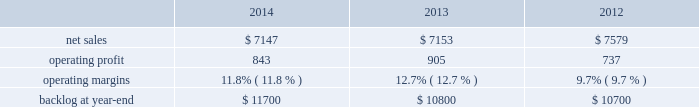Mission systems and training our mst business segment provides ship and submarine mission and combat systems ; mission systems and sensors for rotary and fixed-wing aircraft ; sea and land-based missile defense systems ; radar systems ; littoral combat ships ; simulation and training services ; and unmanned systems and technologies .
Mst 2019s major programs include aegis combat system ( aegis ) , littoral combat ship ( lcs ) , mh-60 , tpq-53 radar system and mk-41 vertical launching system .
Mst 2019s operating results included the following ( in millions ) : .
2014 compared to 2013 mst 2019s net sales for 2014 were comparable to 2013 .
Net sales decreased by approximately $ 85 million for undersea systems programs due to decreased volume and deliveries ; and about $ 55 million related to the settlements of contract cost matters on certain programs ( including a portion of the terminated presidential helicopter program ) in 2013 that were not repeated in 2014 .
The decreases were offset by higher net sales of approximately $ 80 million for integrated warfare systems and sensors programs due to increased volume ( primarily space fence ) ; and approximately $ 40 million for training and logistics solutions programs due to increased deliveries ( primarily close combat tactical trainer ) .
Mst 2019s operating profit for 2014 decreased $ 62 million , or 7% ( 7 % ) , compared to 2013 .
The decrease was primarily attributable to lower operating profit of approximately $ 120 million related to the settlements of contract cost matters on certain programs ( including a portion of the terminated presidential helicopter program ) in 2013 that were not repeated in 2014 ; and approximately $ 45 million due to higher reserves recorded on certain training and logistics solutions programs .
The decreases were partially offset by higher operating profit of approximately $ 45 million for performance matters and reserves recorded in 2013 that were not repeated in 2014 ; and about $ 60 million for various programs due to increased risk retirements ( including mh-60 and radar surveillance programs ) .
Adjustments not related to volume , including net profit booking rate adjustments and other matters , were approximately $ 50 million lower for 2014 compared to 2013 .
2013 compared to 2012 mst 2019s net sales for 2013 decreased $ 426 million , or 6% ( 6 % ) , compared to 2012 .
The decrease was primarily attributable to lower net sales of approximately $ 275 million for various ship and aviation systems programs due to lower volume ( primarily ptds as final surveillance system deliveries occurred during the second quarter of 2012 ) ; about $ 195 million for various integrated warfare systems and sensors programs ( primarily naval systems ) due to lower volume ; approximately $ 65 million for various training and logistics programs due to lower volume ; and about $ 55 million for the aegis program due to lower volume .
The decreases were partially offset by higher net sales of about $ 155 million for the lcs program due to increased volume .
Mst 2019s operating profit for 2013 increased $ 168 million , or 23% ( 23 % ) , compared to 2012 .
The increase was primarily attributable to higher operating profit of approximately $ 120 million related to the settlement of contract cost matters on certain programs ( including a portion of the terminated presidential helicopter program ) ; about $ 55 million for integrated warfare systems and sensors programs ( primarily radar and halifax class modernization programs ) due to increased risk retirements ; and approximately $ 30 million for undersea systems programs due to increased risk retirements .
The increases were partially offset by lower operating profit of about $ 55 million for training and logistics programs , primarily due to the recording of approximately $ 30 million of charges mostly related to lower-of-cost-or-market considerations ; and about $ 25 million for ship and aviation systems programs ( primarily ptds ) due to lower risk retirements and volume .
Operating profit related to the lcs program was comparable .
Adjustments not related to volume , including net profit booking rate adjustments and other matters , were approximately $ 170 million higher for 2013 compared to 2012 .
Backlog backlog increased in 2014 compared to 2013 primarily due to higher orders on new program starts ( such as space fence ) .
Backlog increased slightly in 2013 compared to 2012 mainly due to higher orders and lower sales on integrated warfare system and sensors programs ( primarily aegis ) and lower sales on various service programs , partially offset by lower orders on ship and aviation systems ( primarily mh-60 ) . .
What was the percent of the net sales decline in 2013 attributable to the in part to the various integrated warfare systems and sensors programs - for the naval system lower volume? 
Computations: (195 / 426)
Answer: 0.45775. Mission systems and training our mst business segment provides ship and submarine mission and combat systems ; mission systems and sensors for rotary and fixed-wing aircraft ; sea and land-based missile defense systems ; radar systems ; littoral combat ships ; simulation and training services ; and unmanned systems and technologies .
Mst 2019s major programs include aegis combat system ( aegis ) , littoral combat ship ( lcs ) , mh-60 , tpq-53 radar system and mk-41 vertical launching system .
Mst 2019s operating results included the following ( in millions ) : .
2014 compared to 2013 mst 2019s net sales for 2014 were comparable to 2013 .
Net sales decreased by approximately $ 85 million for undersea systems programs due to decreased volume and deliveries ; and about $ 55 million related to the settlements of contract cost matters on certain programs ( including a portion of the terminated presidential helicopter program ) in 2013 that were not repeated in 2014 .
The decreases were offset by higher net sales of approximately $ 80 million for integrated warfare systems and sensors programs due to increased volume ( primarily space fence ) ; and approximately $ 40 million for training and logistics solutions programs due to increased deliveries ( primarily close combat tactical trainer ) .
Mst 2019s operating profit for 2014 decreased $ 62 million , or 7% ( 7 % ) , compared to 2013 .
The decrease was primarily attributable to lower operating profit of approximately $ 120 million related to the settlements of contract cost matters on certain programs ( including a portion of the terminated presidential helicopter program ) in 2013 that were not repeated in 2014 ; and approximately $ 45 million due to higher reserves recorded on certain training and logistics solutions programs .
The decreases were partially offset by higher operating profit of approximately $ 45 million for performance matters and reserves recorded in 2013 that were not repeated in 2014 ; and about $ 60 million for various programs due to increased risk retirements ( including mh-60 and radar surveillance programs ) .
Adjustments not related to volume , including net profit booking rate adjustments and other matters , were approximately $ 50 million lower for 2014 compared to 2013 .
2013 compared to 2012 mst 2019s net sales for 2013 decreased $ 426 million , or 6% ( 6 % ) , compared to 2012 .
The decrease was primarily attributable to lower net sales of approximately $ 275 million for various ship and aviation systems programs due to lower volume ( primarily ptds as final surveillance system deliveries occurred during the second quarter of 2012 ) ; about $ 195 million for various integrated warfare systems and sensors programs ( primarily naval systems ) due to lower volume ; approximately $ 65 million for various training and logistics programs due to lower volume ; and about $ 55 million for the aegis program due to lower volume .
The decreases were partially offset by higher net sales of about $ 155 million for the lcs program due to increased volume .
Mst 2019s operating profit for 2013 increased $ 168 million , or 23% ( 23 % ) , compared to 2012 .
The increase was primarily attributable to higher operating profit of approximately $ 120 million related to the settlement of contract cost matters on certain programs ( including a portion of the terminated presidential helicopter program ) ; about $ 55 million for integrated warfare systems and sensors programs ( primarily radar and halifax class modernization programs ) due to increased risk retirements ; and approximately $ 30 million for undersea systems programs due to increased risk retirements .
The increases were partially offset by lower operating profit of about $ 55 million for training and logistics programs , primarily due to the recording of approximately $ 30 million of charges mostly related to lower-of-cost-or-market considerations ; and about $ 25 million for ship and aviation systems programs ( primarily ptds ) due to lower risk retirements and volume .
Operating profit related to the lcs program was comparable .
Adjustments not related to volume , including net profit booking rate adjustments and other matters , were approximately $ 170 million higher for 2013 compared to 2012 .
Backlog backlog increased in 2014 compared to 2013 primarily due to higher orders on new program starts ( such as space fence ) .
Backlog increased slightly in 2013 compared to 2012 mainly due to higher orders and lower sales on integrated warfare system and sensors programs ( primarily aegis ) and lower sales on various service programs , partially offset by lower orders on ship and aviation systems ( primarily mh-60 ) . .
What is the growth rate in net sales for mst in 2013? 
Computations: ((7153 - 7579) / 7579)
Answer: -0.05621. Mission systems and training our mst business segment provides ship and submarine mission and combat systems ; mission systems and sensors for rotary and fixed-wing aircraft ; sea and land-based missile defense systems ; radar systems ; littoral combat ships ; simulation and training services ; and unmanned systems and technologies .
Mst 2019s major programs include aegis combat system ( aegis ) , littoral combat ship ( lcs ) , mh-60 , tpq-53 radar system and mk-41 vertical launching system .
Mst 2019s operating results included the following ( in millions ) : .
2014 compared to 2013 mst 2019s net sales for 2014 were comparable to 2013 .
Net sales decreased by approximately $ 85 million for undersea systems programs due to decreased volume and deliveries ; and about $ 55 million related to the settlements of contract cost matters on certain programs ( including a portion of the terminated presidential helicopter program ) in 2013 that were not repeated in 2014 .
The decreases were offset by higher net sales of approximately $ 80 million for integrated warfare systems and sensors programs due to increased volume ( primarily space fence ) ; and approximately $ 40 million for training and logistics solutions programs due to increased deliveries ( primarily close combat tactical trainer ) .
Mst 2019s operating profit for 2014 decreased $ 62 million , or 7% ( 7 % ) , compared to 2013 .
The decrease was primarily attributable to lower operating profit of approximately $ 120 million related to the settlements of contract cost matters on certain programs ( including a portion of the terminated presidential helicopter program ) in 2013 that were not repeated in 2014 ; and approximately $ 45 million due to higher reserves recorded on certain training and logistics solutions programs .
The decreases were partially offset by higher operating profit of approximately $ 45 million for performance matters and reserves recorded in 2013 that were not repeated in 2014 ; and about $ 60 million for various programs due to increased risk retirements ( including mh-60 and radar surveillance programs ) .
Adjustments not related to volume , including net profit booking rate adjustments and other matters , were approximately $ 50 million lower for 2014 compared to 2013 .
2013 compared to 2012 mst 2019s net sales for 2013 decreased $ 426 million , or 6% ( 6 % ) , compared to 2012 .
The decrease was primarily attributable to lower net sales of approximately $ 275 million for various ship and aviation systems programs due to lower volume ( primarily ptds as final surveillance system deliveries occurred during the second quarter of 2012 ) ; about $ 195 million for various integrated warfare systems and sensors programs ( primarily naval systems ) due to lower volume ; approximately $ 65 million for various training and logistics programs due to lower volume ; and about $ 55 million for the aegis program due to lower volume .
The decreases were partially offset by higher net sales of about $ 155 million for the lcs program due to increased volume .
Mst 2019s operating profit for 2013 increased $ 168 million , or 23% ( 23 % ) , compared to 2012 .
The increase was primarily attributable to higher operating profit of approximately $ 120 million related to the settlement of contract cost matters on certain programs ( including a portion of the terminated presidential helicopter program ) ; about $ 55 million for integrated warfare systems and sensors programs ( primarily radar and halifax class modernization programs ) due to increased risk retirements ; and approximately $ 30 million for undersea systems programs due to increased risk retirements .
The increases were partially offset by lower operating profit of about $ 55 million for training and logistics programs , primarily due to the recording of approximately $ 30 million of charges mostly related to lower-of-cost-or-market considerations ; and about $ 25 million for ship and aviation systems programs ( primarily ptds ) due to lower risk retirements and volume .
Operating profit related to the lcs program was comparable .
Adjustments not related to volume , including net profit booking rate adjustments and other matters , were approximately $ 170 million higher for 2013 compared to 2012 .
Backlog backlog increased in 2014 compared to 2013 primarily due to higher orders on new program starts ( such as space fence ) .
Backlog increased slightly in 2013 compared to 2012 mainly due to higher orders and lower sales on integrated warfare system and sensors programs ( primarily aegis ) and lower sales on various service programs , partially offset by lower orders on ship and aviation systems ( primarily mh-60 ) . .
What was the percentage change in the backlog from 2013 to 2014? 
Computations: ((11700 - 10800) / 10800)
Answer: 0.08333. 